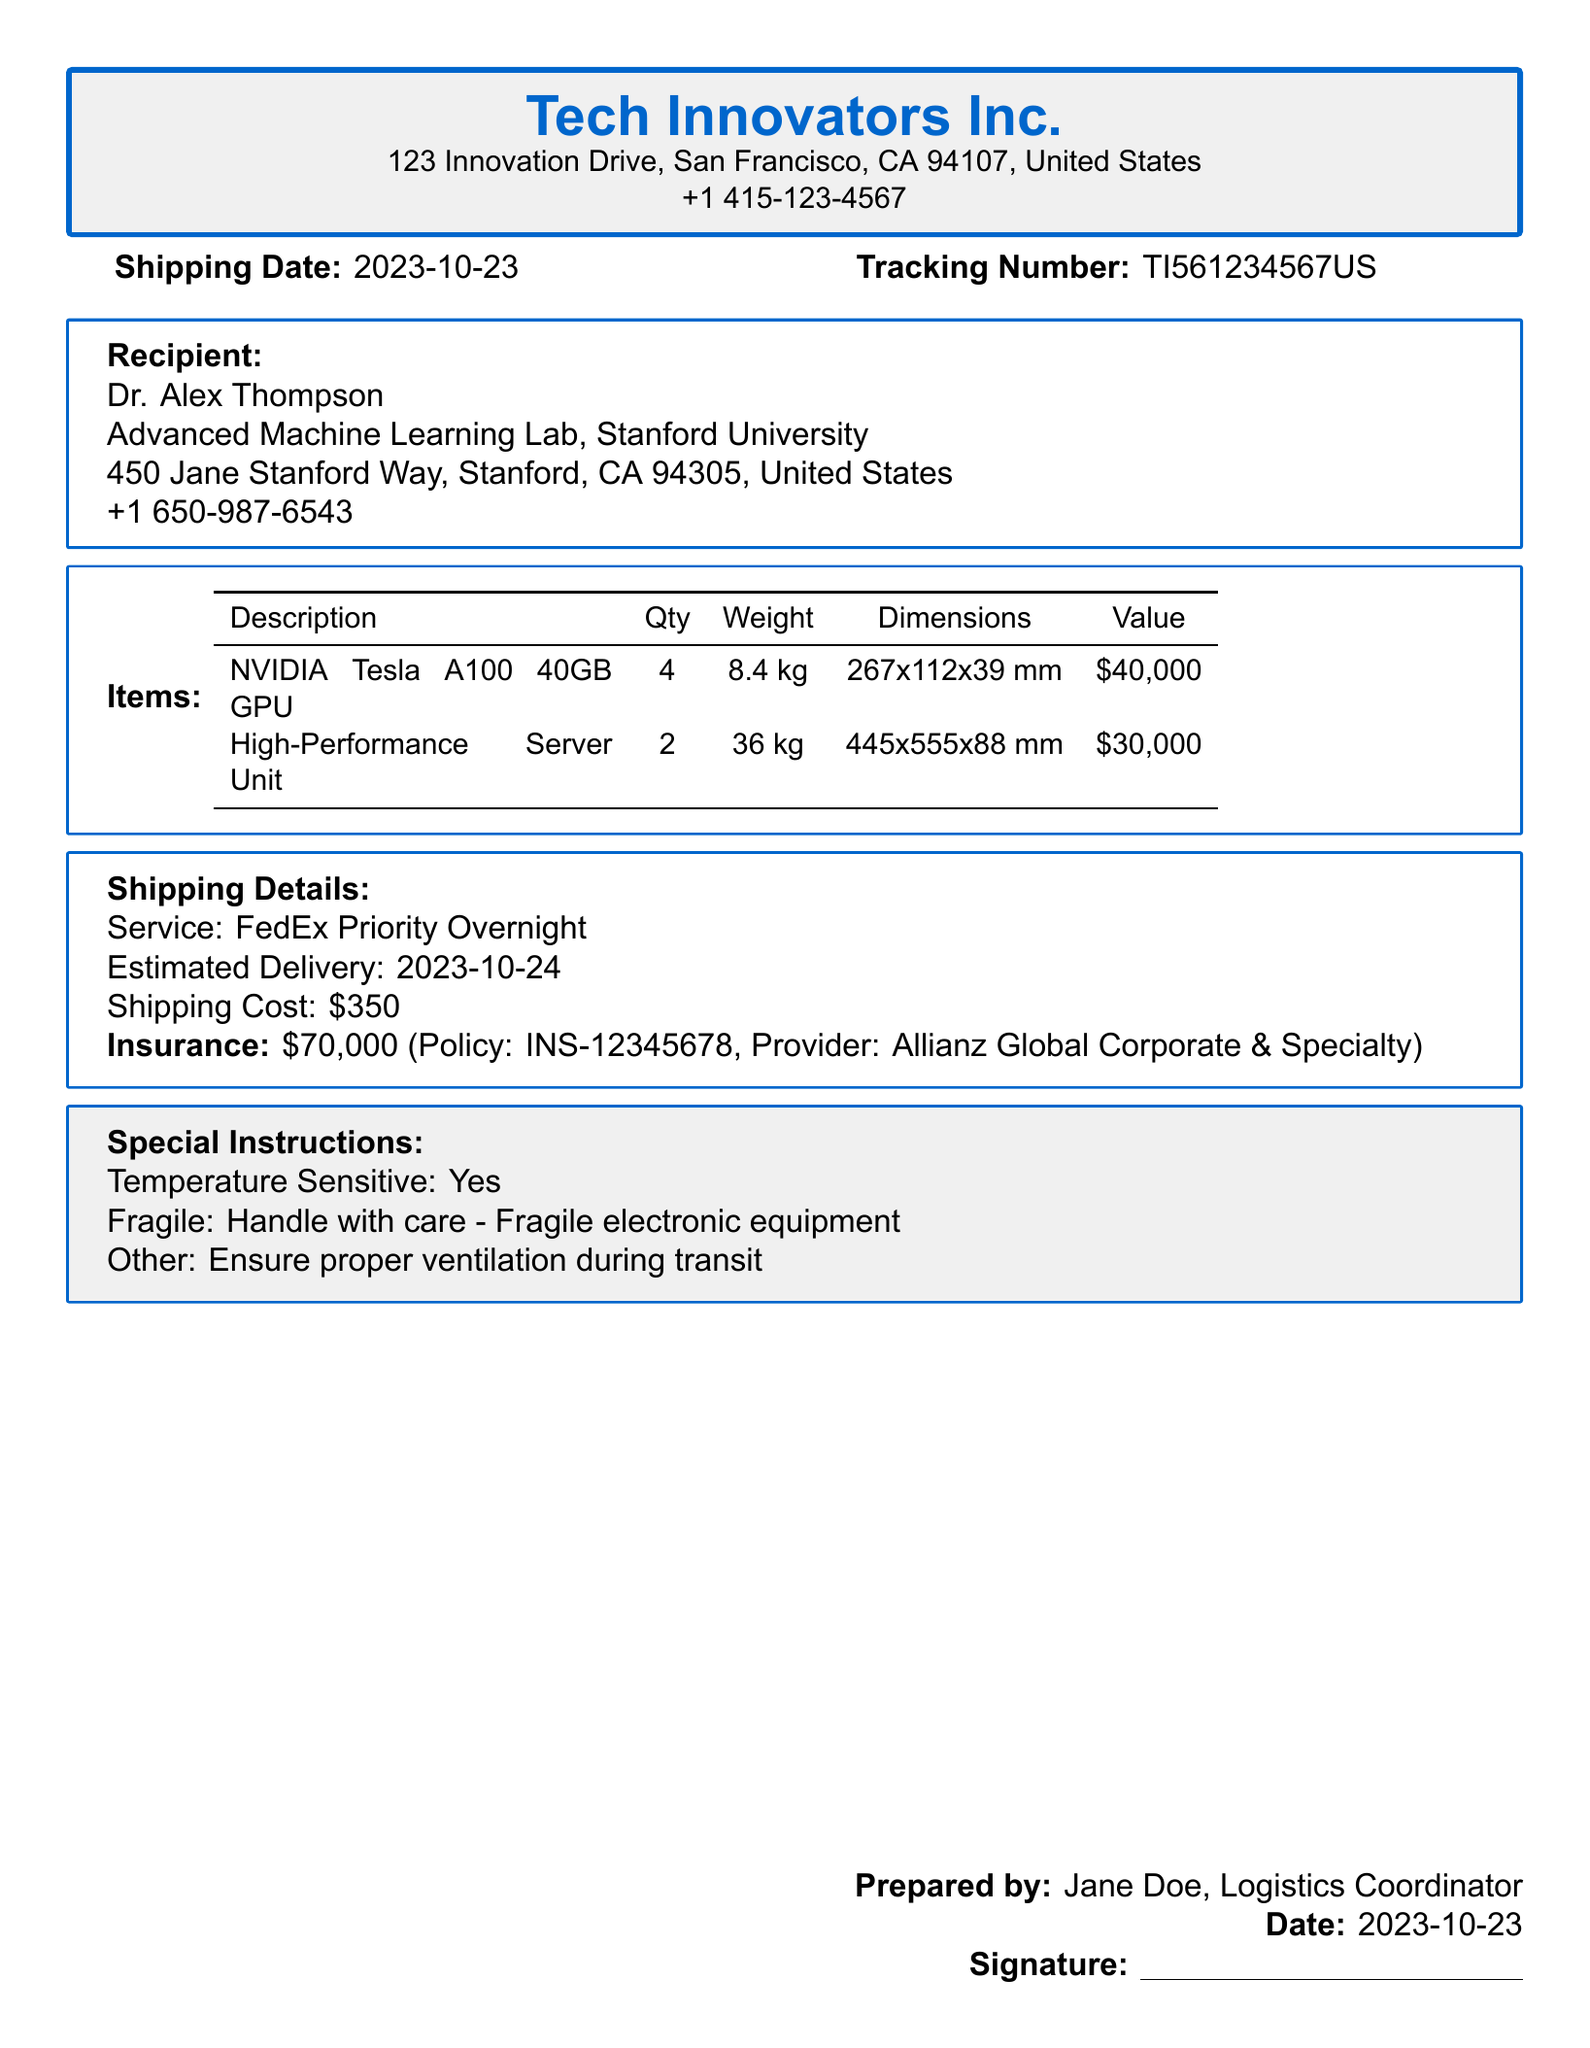what is the shipping date? The shipping date is directly stated in the document under the "Shipping Date" section.
Answer: 2023-10-23 who is the recipient of the package? The recipient's name is found in the "Recipient" section of the document.
Answer: Dr. Alex Thompson how many NVIDIA Tesla A100 GPUs are being shipped? The quantity of GPUs is specified in the itemized list of the document.
Answer: 4 what is the estimated delivery date? The estimated delivery date is listed in the "Shipping Details" section of the document.
Answer: 2023-10-24 what is the total value of the items being shipped? The total value can be derived from the individual values of each item listed in the table.
Answer: $70,000 what insurance amount is provided for this shipment? The insurance amount is specified in the "Shipping Details" section of the document.
Answer: $70,000 what is the shipping service used for delivery? The shipping service is noted in the "Shipping Details" section of the document.
Answer: FedEx Priority Overnight how much does the shipping cost? The shipping cost is explicitly mentioned in the "Shipping Details" section.
Answer: $350 what are the special instructions for handling the package? The special instructions regarding the package handling are outlined in the respective section.
Answer: Temperature Sensitive: Yes 